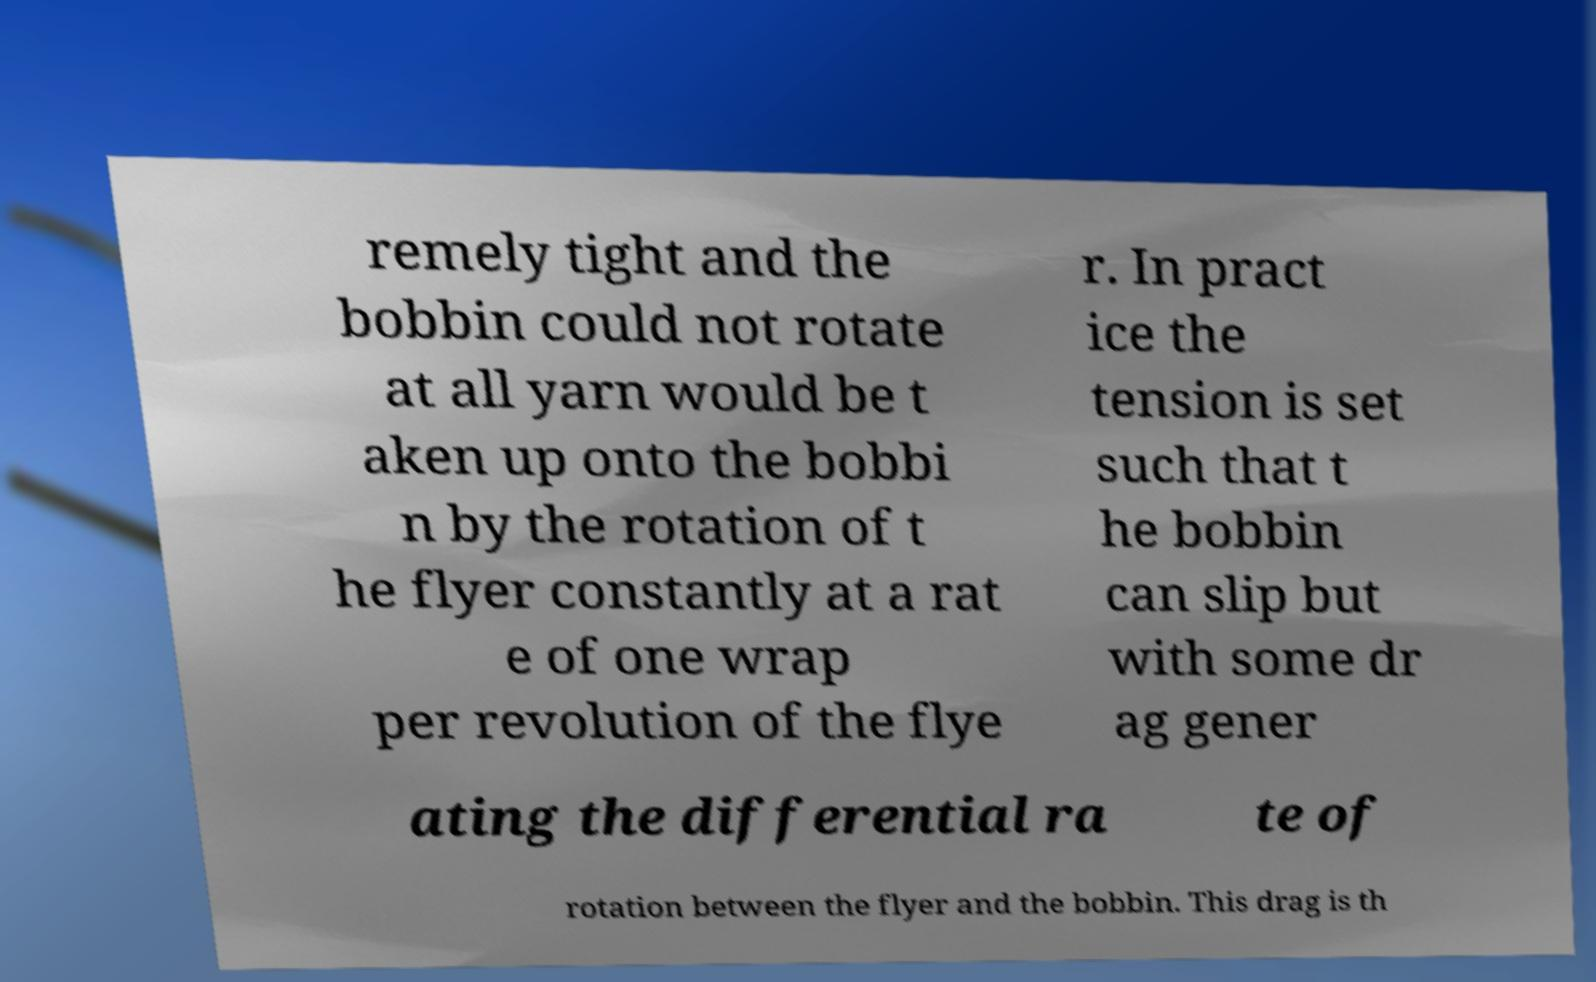Can you read and provide the text displayed in the image?This photo seems to have some interesting text. Can you extract and type it out for me? remely tight and the bobbin could not rotate at all yarn would be t aken up onto the bobbi n by the rotation of t he flyer constantly at a rat e of one wrap per revolution of the flye r. In pract ice the tension is set such that t he bobbin can slip but with some dr ag gener ating the differential ra te of rotation between the flyer and the bobbin. This drag is th 